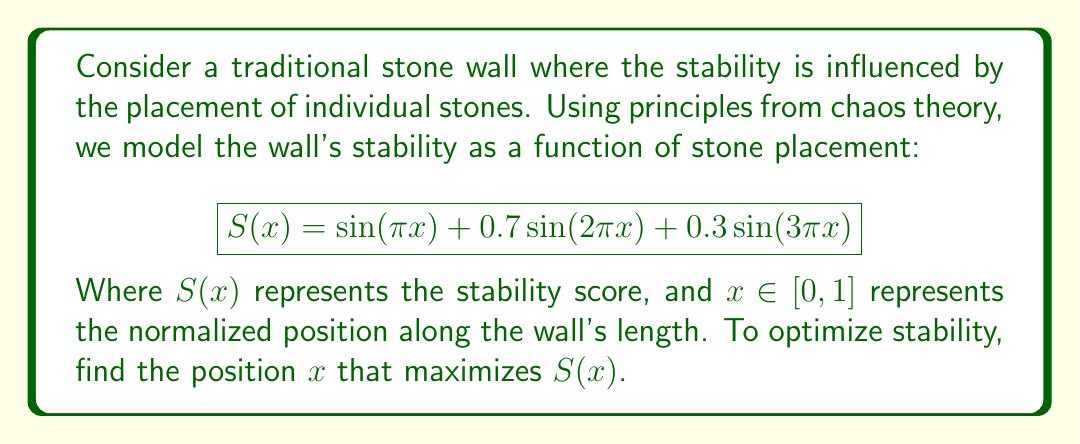Help me with this question. 1) To find the maximum of $S(x)$, we need to find where its derivative equals zero:

   $$S'(x) = π\cos(πx) + 1.4π\cos(2πx) + 0.9π\cos(3πx)$$

2) Set $S'(x) = 0$:

   $$π\cos(πx) + 1.4π\cos(2πx) + 0.9π\cos(3πx) = 0$$

3) This equation is transcendental and cannot be solved algebraically. We need to use numerical methods.

4) Using a graphing calculator or computer software, we can plot $S'(x)$ and find where it crosses the x-axis.

5) The solution is approximately $x ≈ 0.2157$.

6) To verify this is a maximum, we can check the second derivative:

   $$S''(0.2157) = -π^2\sin(π(0.2157)) - 2.8π^2\sin(2π(0.2157)) - 2.7π^2\sin(3π(0.2157)) ≈ -29.4 < 0$$

   Since $S''(0.2157) < 0$, this confirms it's a local maximum.

7) The stability score at this position is:

   $$S(0.2157) ≈ 1.9847$$

This represents the optimal placement for maximum stability according to our chaos theory model.
Answer: $x ≈ 0.2157$ 